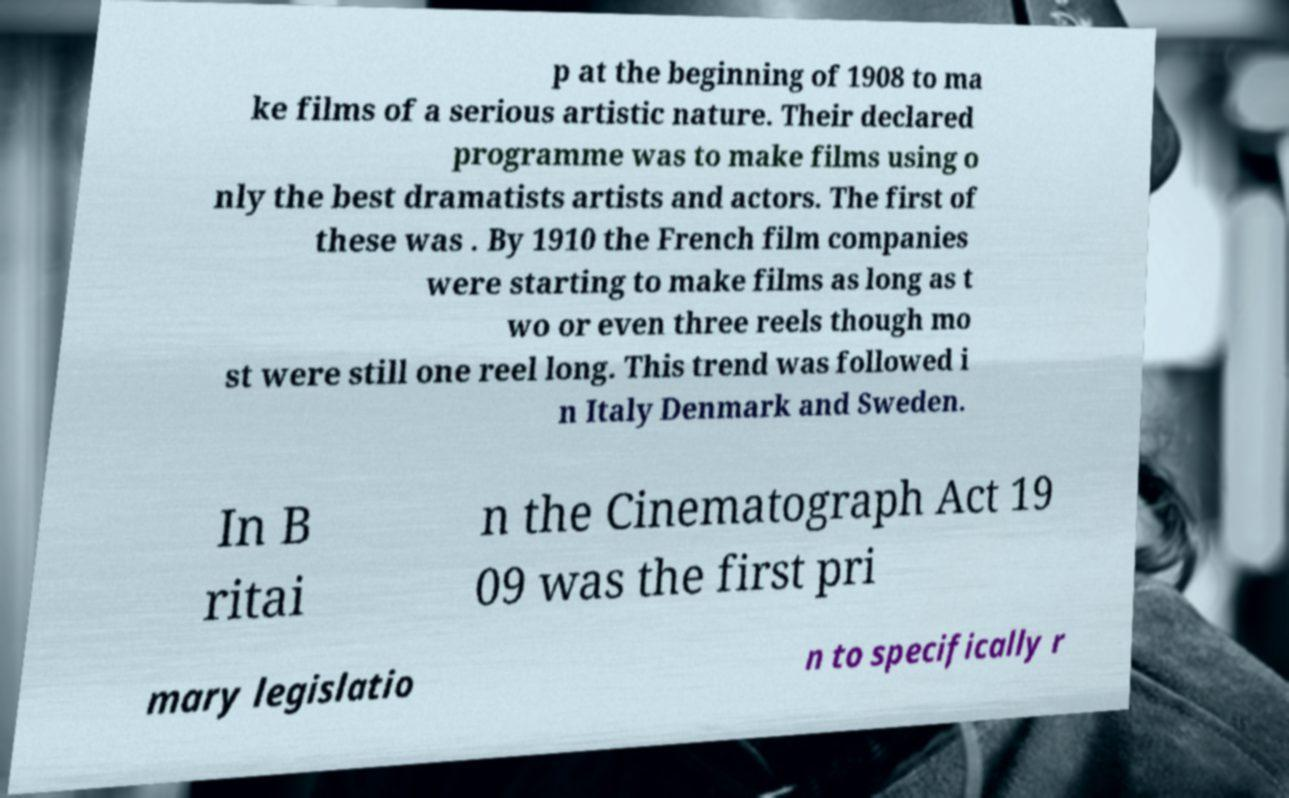There's text embedded in this image that I need extracted. Can you transcribe it verbatim? p at the beginning of 1908 to ma ke films of a serious artistic nature. Their declared programme was to make films using o nly the best dramatists artists and actors. The first of these was . By 1910 the French film companies were starting to make films as long as t wo or even three reels though mo st were still one reel long. This trend was followed i n Italy Denmark and Sweden. In B ritai n the Cinematograph Act 19 09 was the first pri mary legislatio n to specifically r 